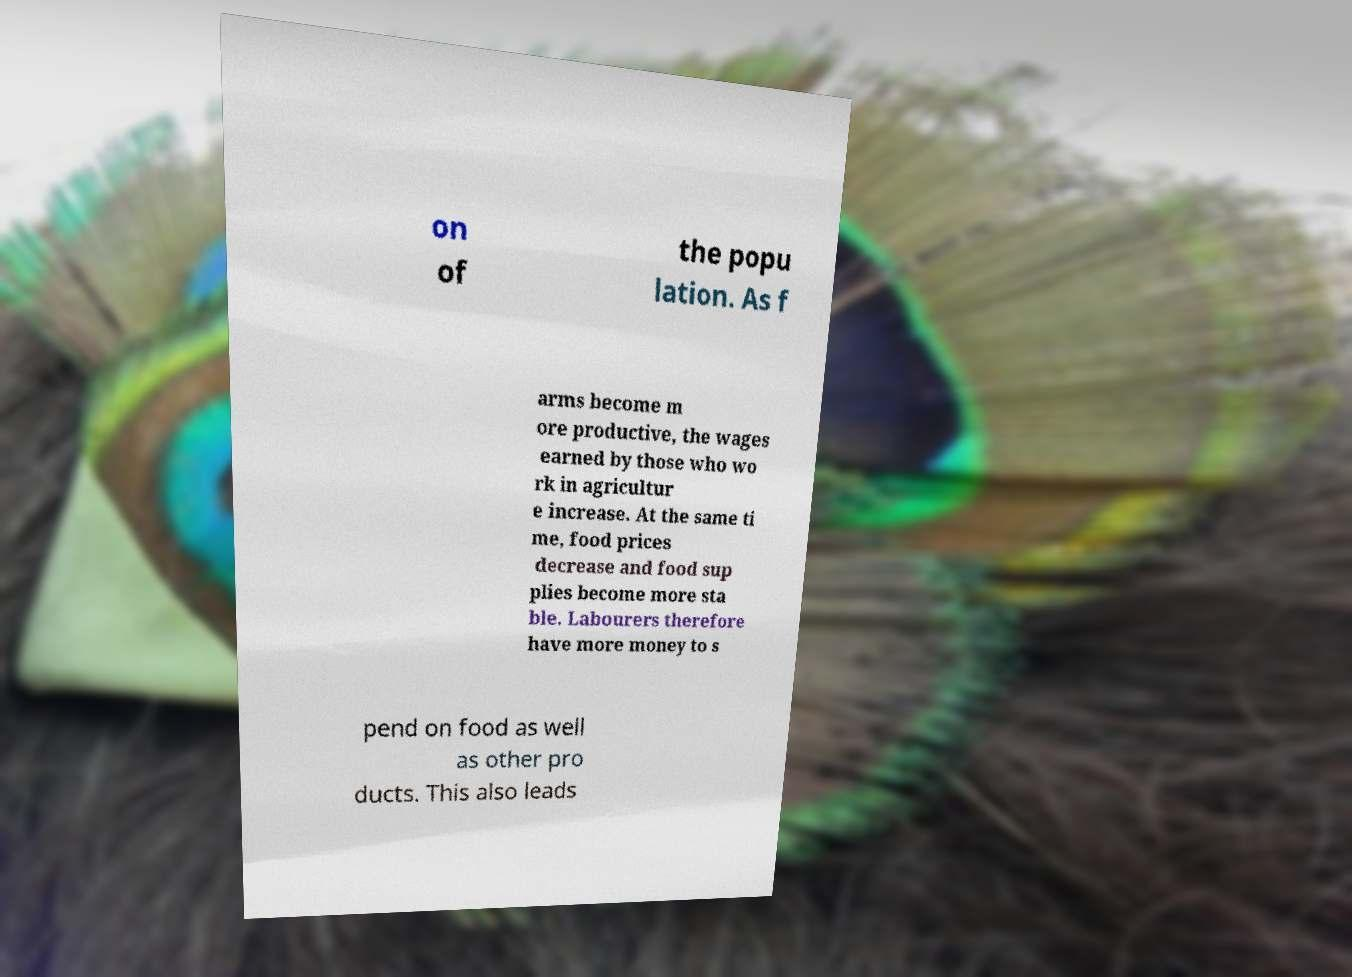There's text embedded in this image that I need extracted. Can you transcribe it verbatim? on of the popu lation. As f arms become m ore productive, the wages earned by those who wo rk in agricultur e increase. At the same ti me, food prices decrease and food sup plies become more sta ble. Labourers therefore have more money to s pend on food as well as other pro ducts. This also leads 